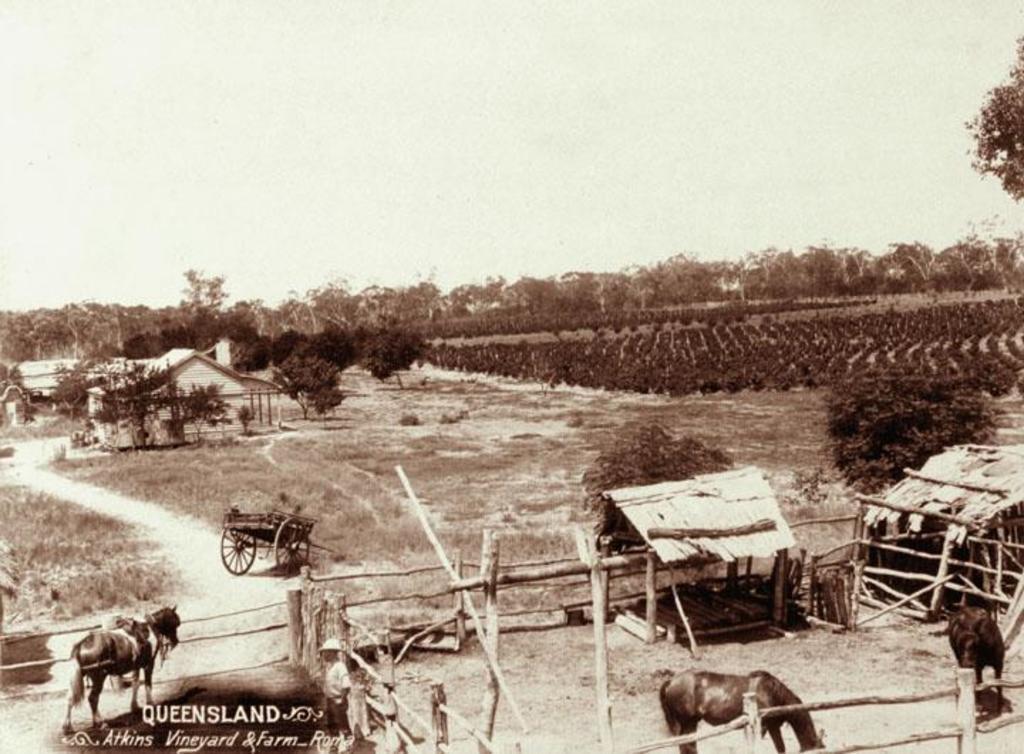Please provide a concise description of this image. In this image there is an old photograph, in the photograph there are horses, bullock carts, wooden fence, grass huts, trees and crops. 